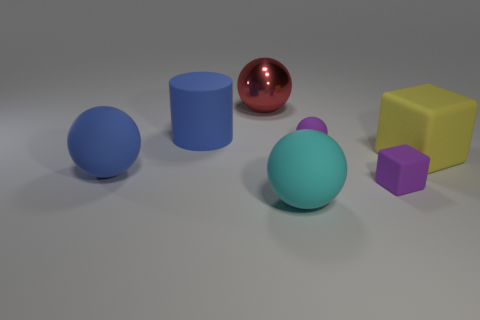Is the size of the metallic sphere the same as the purple cube?
Offer a very short reply. No. How big is the cyan rubber sphere?
Your answer should be very brief. Large. Is the number of tiny purple spheres to the left of the large block greater than the number of tiny metallic cylinders?
Make the answer very short. Yes. There is a large thing that is in front of the big matte sphere behind the large sphere to the right of the large metallic object; what is its shape?
Keep it short and to the point. Sphere. There is a cyan matte sphere that is on the right side of the shiny sphere; is its size the same as the small sphere?
Give a very brief answer. No. There is a object that is both on the left side of the tiny rubber sphere and in front of the big blue rubber ball; what shape is it?
Provide a succinct answer. Sphere. Is the color of the big matte cylinder the same as the matte sphere to the left of the large red ball?
Your answer should be very brief. Yes. There is a small rubber object that is behind the big rubber object that is to the right of the ball in front of the big blue sphere; what is its color?
Your answer should be very brief. Purple. There is another tiny object that is the same shape as the red object; what is its color?
Offer a terse response. Purple. Are there an equal number of big blue rubber spheres that are behind the large cylinder and yellow shiny cylinders?
Your answer should be very brief. Yes. 